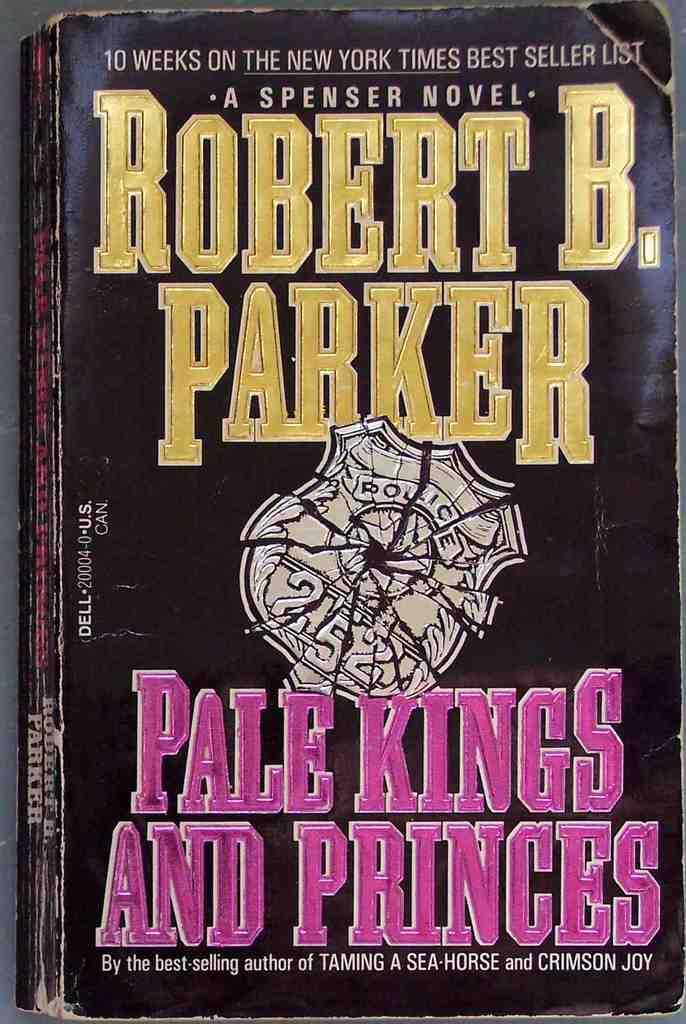What object can be seen in the image? There is a book in the image. Can you describe the book in the image? The book appears to be a hardcover book with a visible spine. What might someone be doing with the book in the image? Someone might be reading or holding the book in the image. What type of sail can be seen on the book in the image? There is no sail present on the book in the image, as it is a stationary object. 